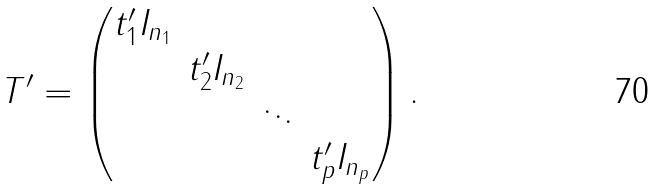Convert formula to latex. <formula><loc_0><loc_0><loc_500><loc_500>T ^ { \prime } = \begin{pmatrix} t ^ { \prime } _ { 1 } I _ { n _ { 1 } } & & & \\ & t ^ { \prime } _ { 2 } I _ { n _ { 2 } } & & \\ & & \ddots & \\ & & & t ^ { \prime } _ { p } I _ { n _ { p } } \end{pmatrix} .</formula> 